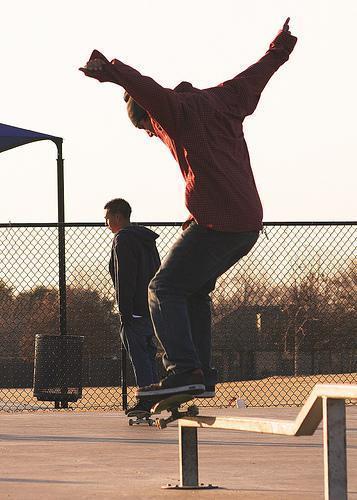How many people are in the photo?
Give a very brief answer. 2. How many skate boards are there?
Give a very brief answer. 2. 